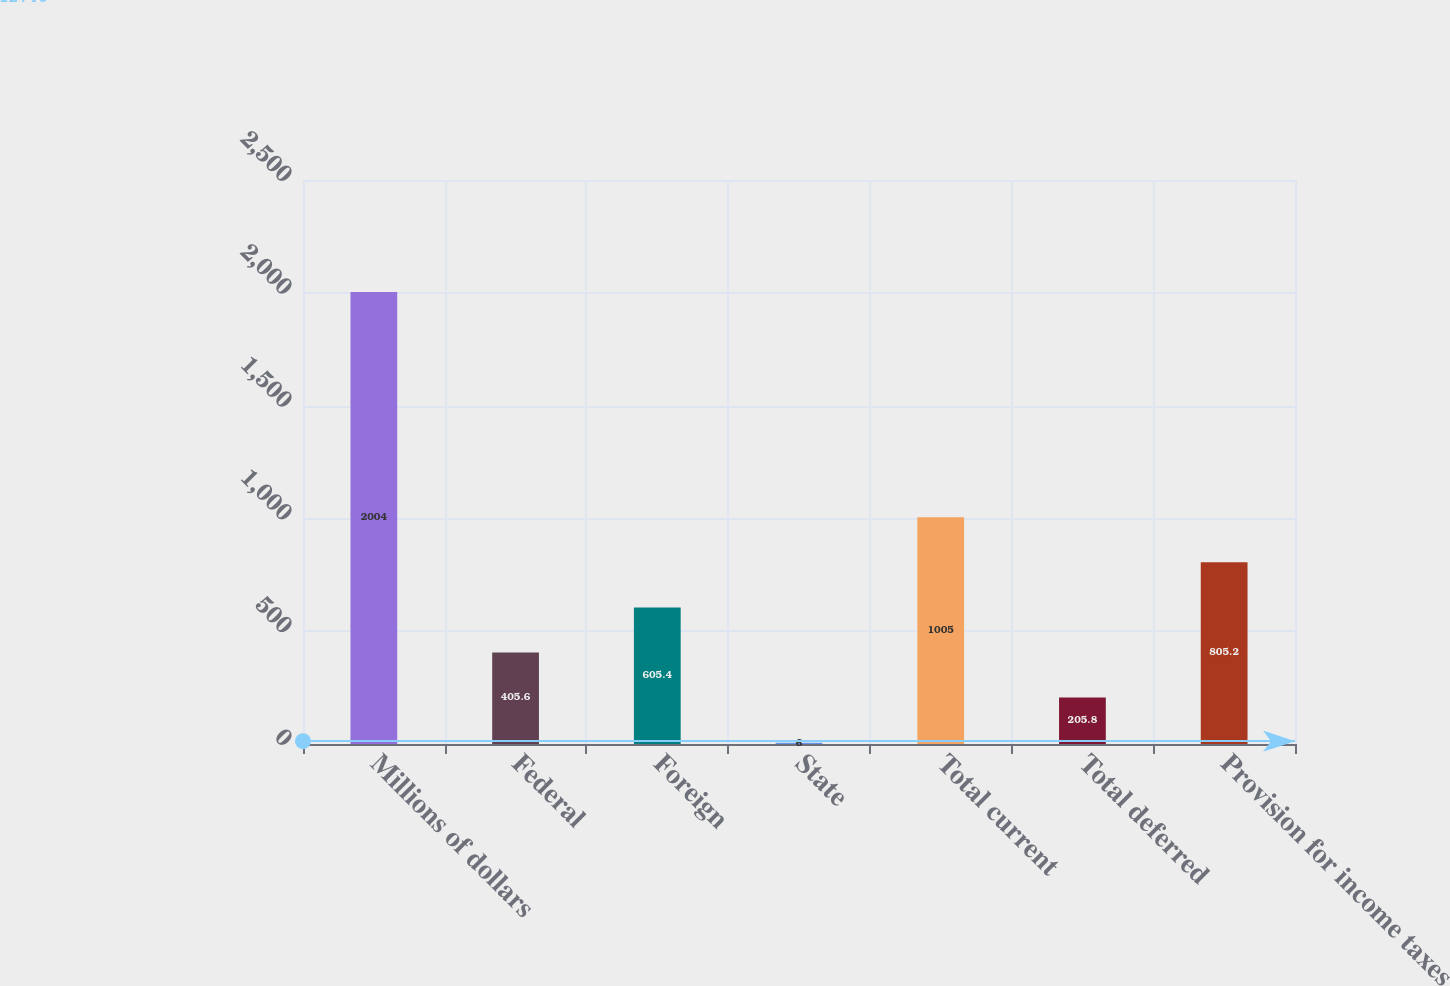Convert chart. <chart><loc_0><loc_0><loc_500><loc_500><bar_chart><fcel>Millions of dollars<fcel>Federal<fcel>Foreign<fcel>State<fcel>Total current<fcel>Total deferred<fcel>Provision for income taxes<nl><fcel>2004<fcel>405.6<fcel>605.4<fcel>6<fcel>1005<fcel>205.8<fcel>805.2<nl></chart> 